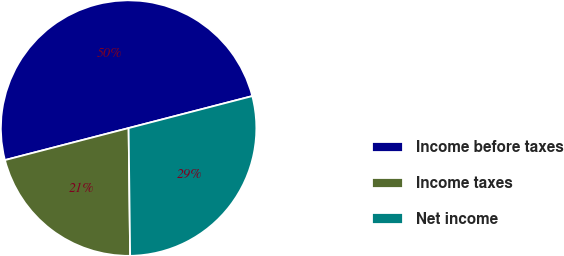Convert chart. <chart><loc_0><loc_0><loc_500><loc_500><pie_chart><fcel>Income before taxes<fcel>Income taxes<fcel>Net income<nl><fcel>50.0%<fcel>21.16%<fcel>28.84%<nl></chart> 